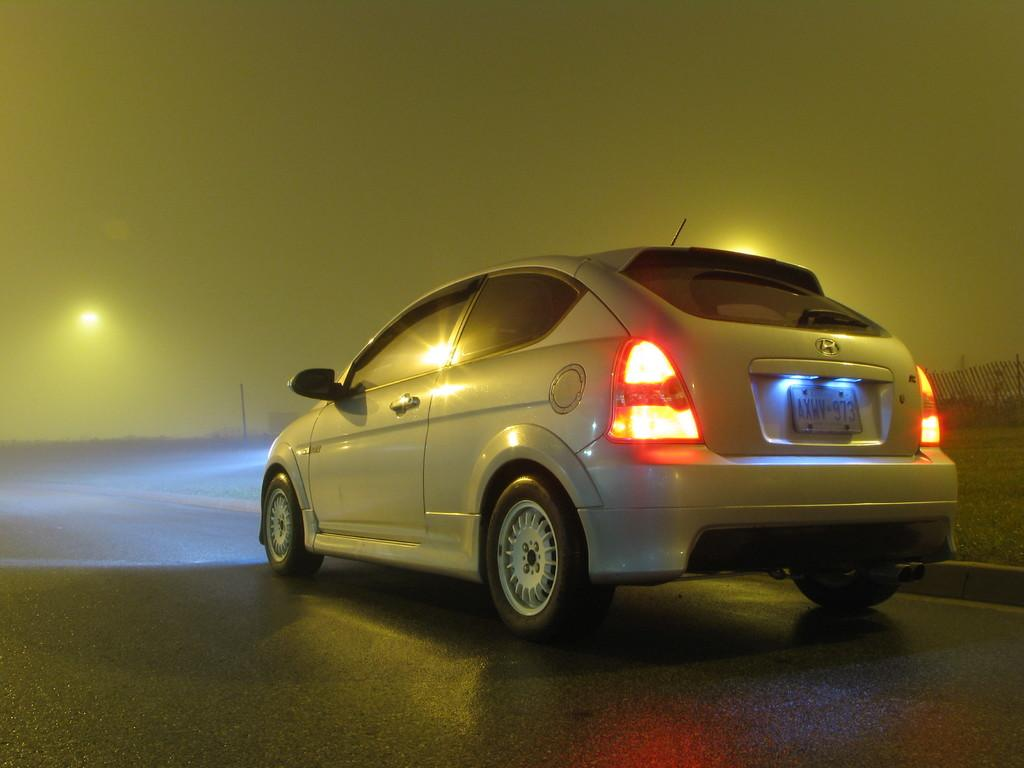<image>
Provide a brief description of the given image. A Hyundai car with the plate number AXWV-973 out for a drive on a foggy night. 